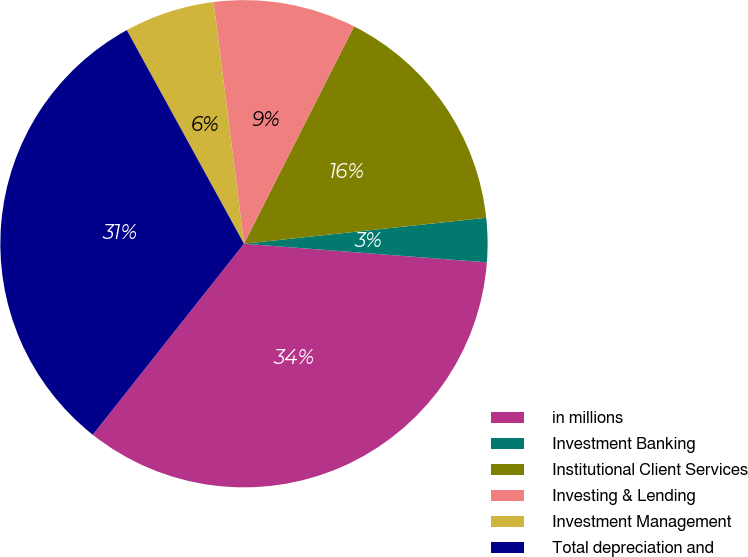Convert chart to OTSL. <chart><loc_0><loc_0><loc_500><loc_500><pie_chart><fcel>in millions<fcel>Investment Banking<fcel>Institutional Client Services<fcel>Investing & Lending<fcel>Investment Management<fcel>Total depreciation and<nl><fcel>34.44%<fcel>2.92%<fcel>15.84%<fcel>9.45%<fcel>6.0%<fcel>31.36%<nl></chart> 